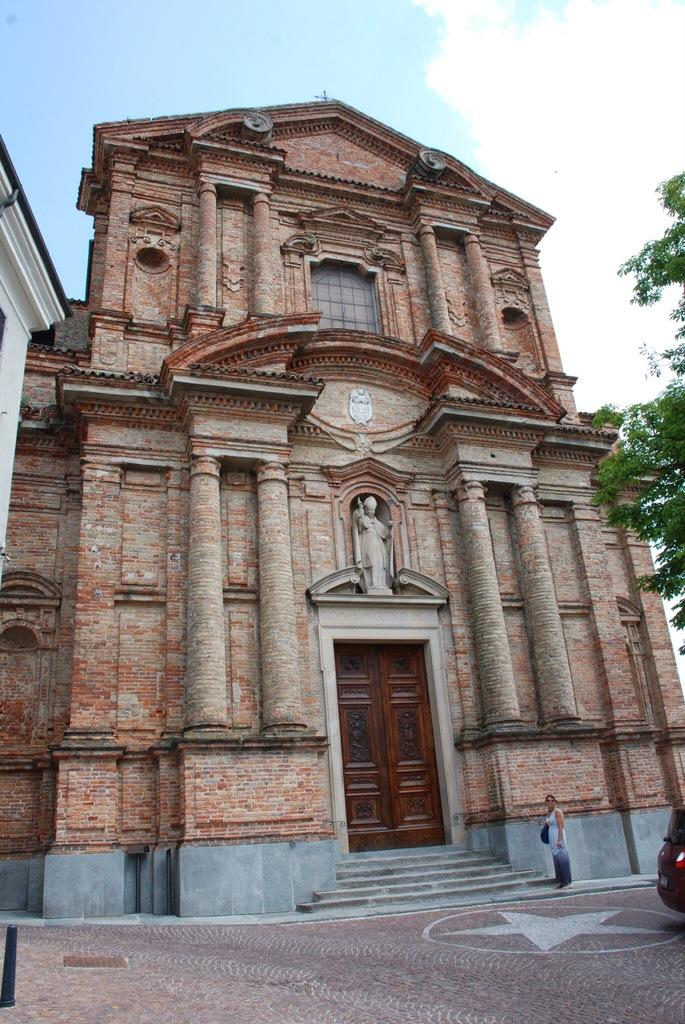What type of structures are visible in the image? There are buildings in the image. What natural element is present in the image? There is a tree in the image. What mode of transportation can be seen on the right side of the image? There is a car on the right side of the image. Who is present in the image? There is a woman standing in the image. What accessory is the woman wearing? The woman is wearing a handbag. How would you describe the sky in the image? The sky is blue and cloudy. How many hooks are hanging from the tree in the image? There are no hooks present in the image; it features a tree, buildings, a car, a woman, and a handbag. What type of account does the woman have in the image? There is no mention of an account in the image; it focuses on the woman, her handbag, and the surrounding environment. 